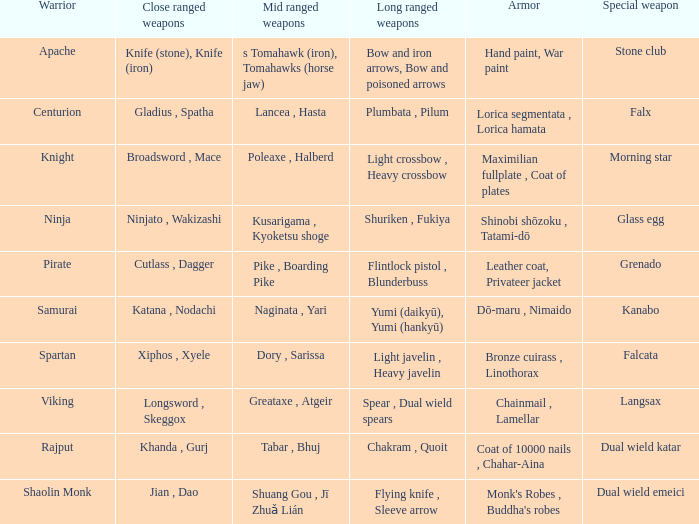If the special weapon is glass egg, what is the close ranged weapon? Ninjato , Wakizashi. 